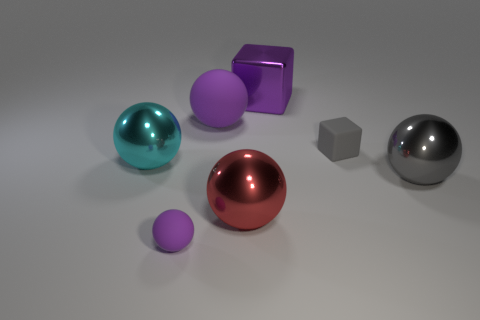Is the material of the big object in front of the big gray metal ball the same as the big gray object? Based on the image, it seems that the big object in front of the big gray metal ball has a similar specular reflection and surface characteristics to the big gray object, which indicates that they could be made of the same or similar type of metallic material. 